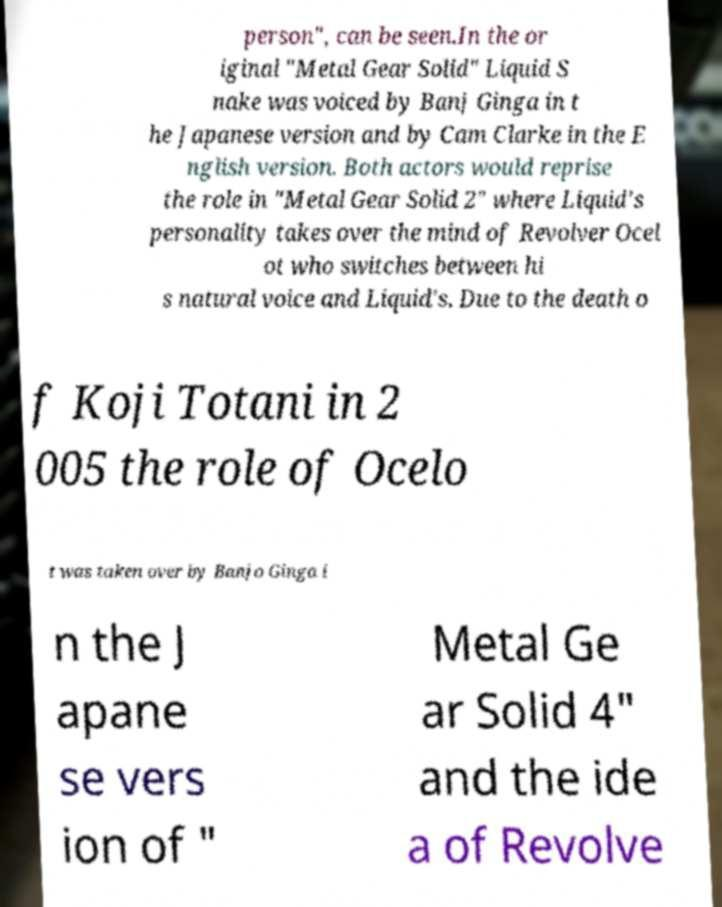Could you extract and type out the text from this image? person", can be seen.In the or iginal "Metal Gear Solid" Liquid S nake was voiced by Banj Ginga in t he Japanese version and by Cam Clarke in the E nglish version. Both actors would reprise the role in "Metal Gear Solid 2" where Liquid's personality takes over the mind of Revolver Ocel ot who switches between hi s natural voice and Liquid's. Due to the death o f Koji Totani in 2 005 the role of Ocelo t was taken over by Banjo Ginga i n the J apane se vers ion of " Metal Ge ar Solid 4" and the ide a of Revolve 